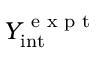Convert formula to latex. <formula><loc_0><loc_0><loc_500><loc_500>Y _ { i n t } ^ { e x p t }</formula> 